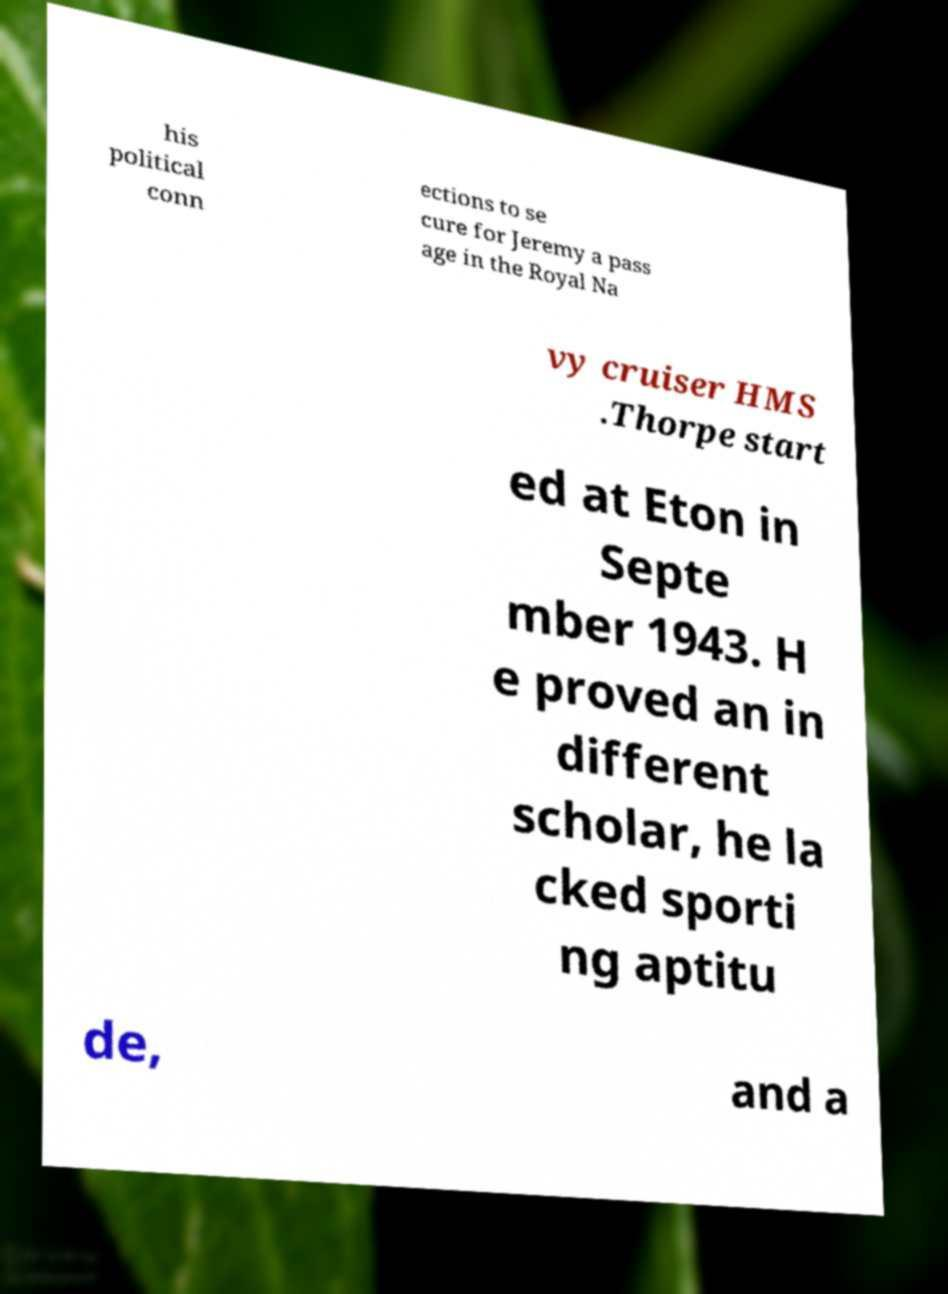Please read and relay the text visible in this image. What does it say? his political conn ections to se cure for Jeremy a pass age in the Royal Na vy cruiser HMS .Thorpe start ed at Eton in Septe mber 1943. H e proved an in different scholar, he la cked sporti ng aptitu de, and a 